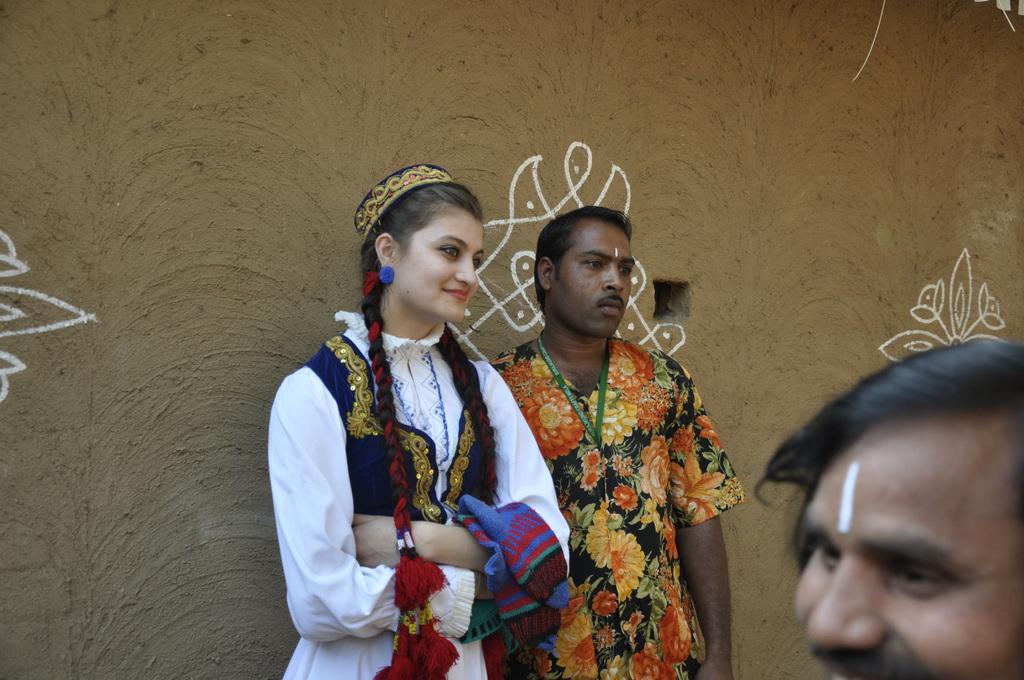How would you summarize this image in a sentence or two? In this picture I can see a man and a woman who are standing in the middle of this image and I see the wall behind on them, on which there are designs and on the right bottom of this image I see another man. 